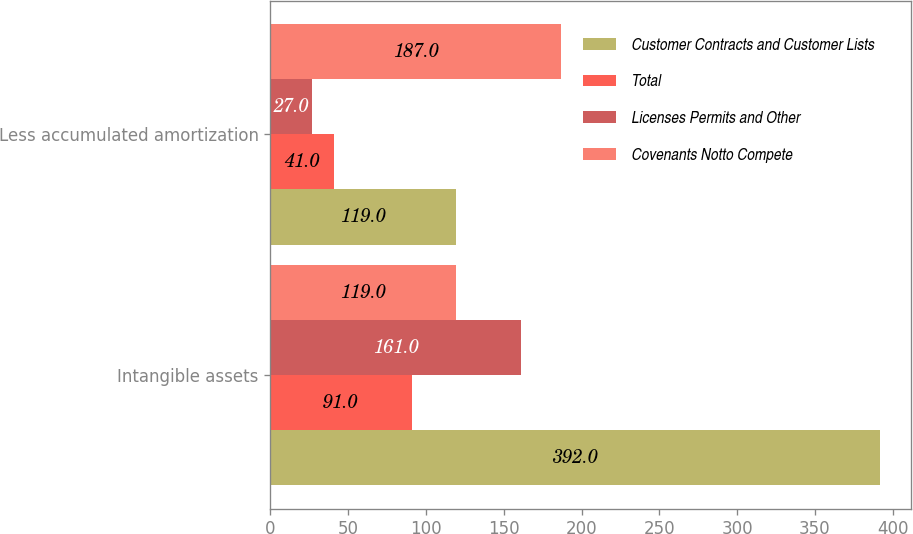Convert chart. <chart><loc_0><loc_0><loc_500><loc_500><stacked_bar_chart><ecel><fcel>Intangible assets<fcel>Less accumulated amortization<nl><fcel>Customer Contracts and Customer Lists<fcel>392<fcel>119<nl><fcel>Total<fcel>91<fcel>41<nl><fcel>Licenses Permits and Other<fcel>161<fcel>27<nl><fcel>Covenants Notto Compete<fcel>119<fcel>187<nl></chart> 